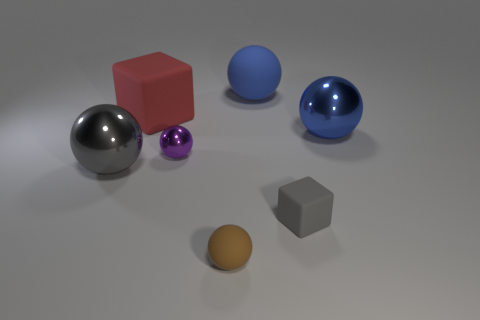Subtract 2 balls. How many balls are left? 3 Subtract all brown balls. How many balls are left? 4 Subtract all big rubber balls. How many balls are left? 4 Subtract all cyan balls. Subtract all yellow cylinders. How many balls are left? 5 Add 2 big metal spheres. How many objects exist? 9 Subtract all blocks. How many objects are left? 5 Add 5 big red matte blocks. How many big red matte blocks are left? 6 Add 5 tiny brown balls. How many tiny brown balls exist? 6 Subtract 0 gray cylinders. How many objects are left? 7 Subtract all gray spheres. Subtract all red cubes. How many objects are left? 5 